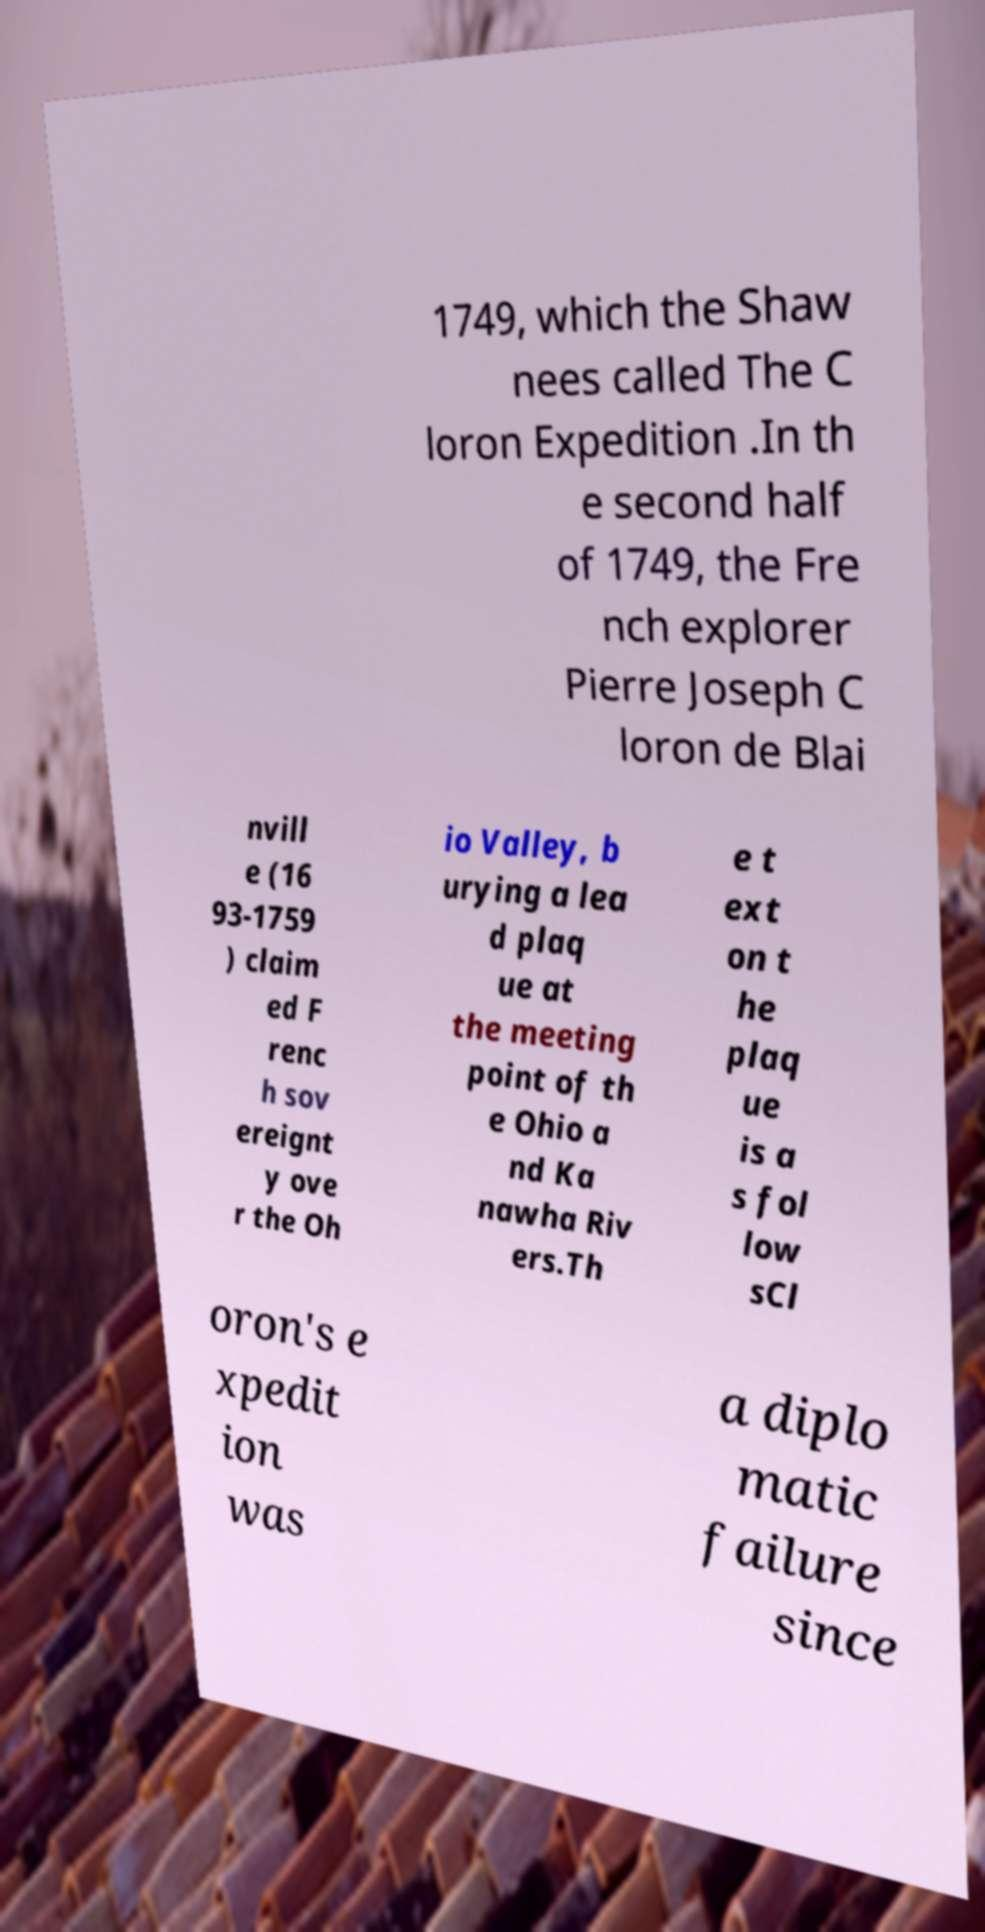Could you extract and type out the text from this image? 1749, which the Shaw nees called The C loron Expedition .In th e second half of 1749, the Fre nch explorer Pierre Joseph C loron de Blai nvill e (16 93-1759 ) claim ed F renc h sov ereignt y ove r the Oh io Valley, b urying a lea d plaq ue at the meeting point of th e Ohio a nd Ka nawha Riv ers.Th e t ext on t he plaq ue is a s fol low sCl oron's e xpedit ion was a diplo matic failure since 